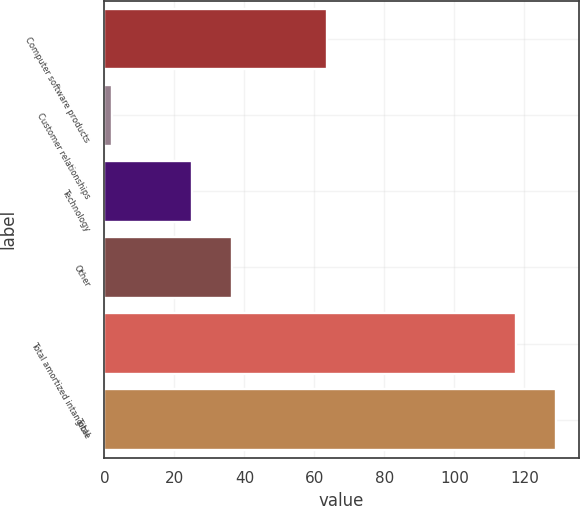Convert chart. <chart><loc_0><loc_0><loc_500><loc_500><bar_chart><fcel>Computer software products<fcel>Customer relationships<fcel>Technology<fcel>Other<fcel>Total amortized intangible<fcel>Total<nl><fcel>63.5<fcel>2.1<fcel>25<fcel>36.54<fcel>117.5<fcel>129.04<nl></chart> 